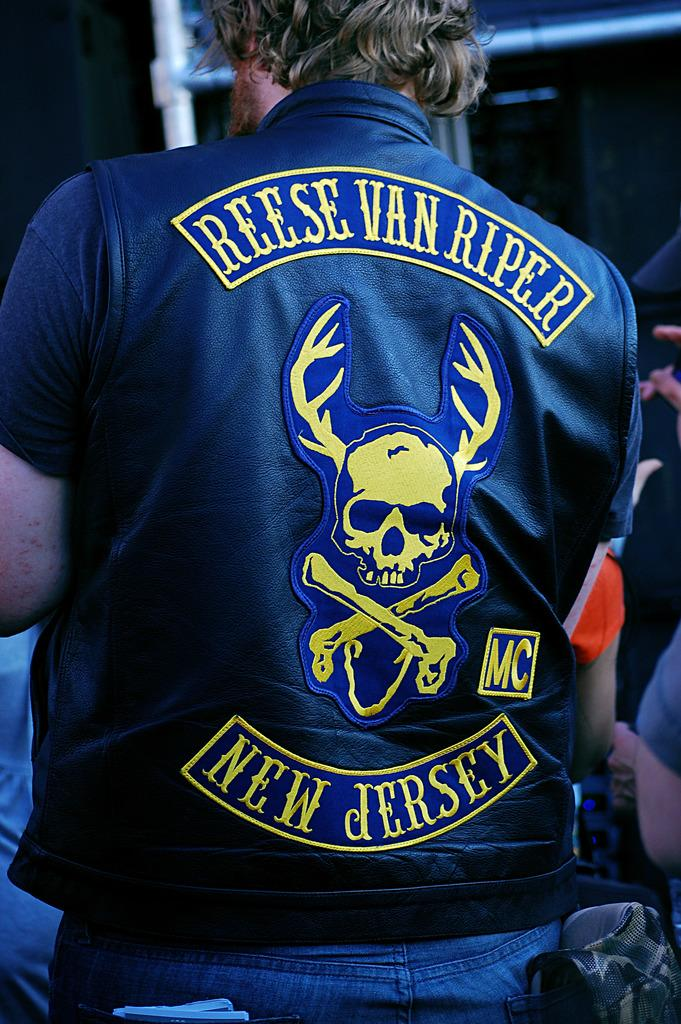Provide a one-sentence caption for the provided image. A man wearing a biker jacket from a New Jersey motorcycle club. 